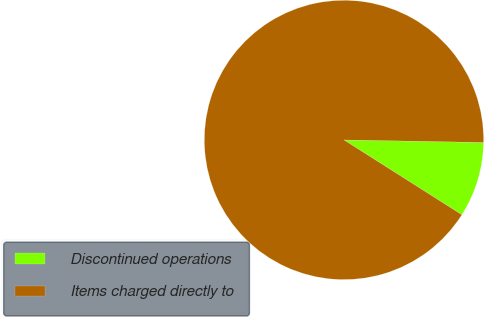Convert chart to OTSL. <chart><loc_0><loc_0><loc_500><loc_500><pie_chart><fcel>Discontinued operations<fcel>Items charged directly to<nl><fcel>8.71%<fcel>91.29%<nl></chart> 